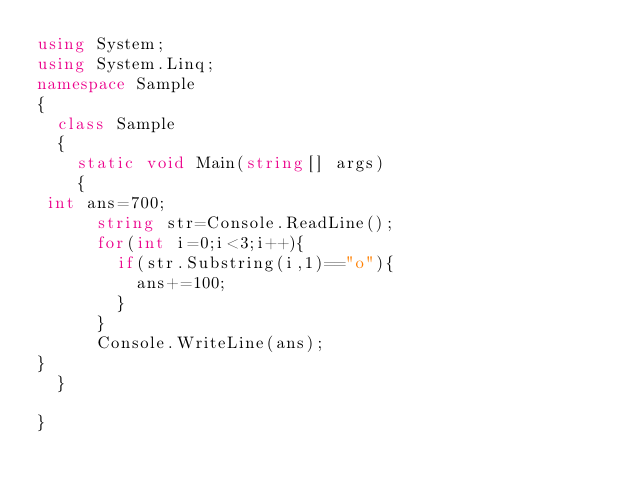Convert code to text. <code><loc_0><loc_0><loc_500><loc_500><_C#_>using System;
using System.Linq;
namespace Sample
{
  class Sample
  {
    static void Main(string[] args)
    {
 int ans=700;
      string str=Console.ReadLine();
      for(int i=0;i<3;i++){
        if(str.Substring(i,1)=="o"){
          ans+=100;
        }
      }
      Console.WriteLine(ans);
}
  }

}
</code> 